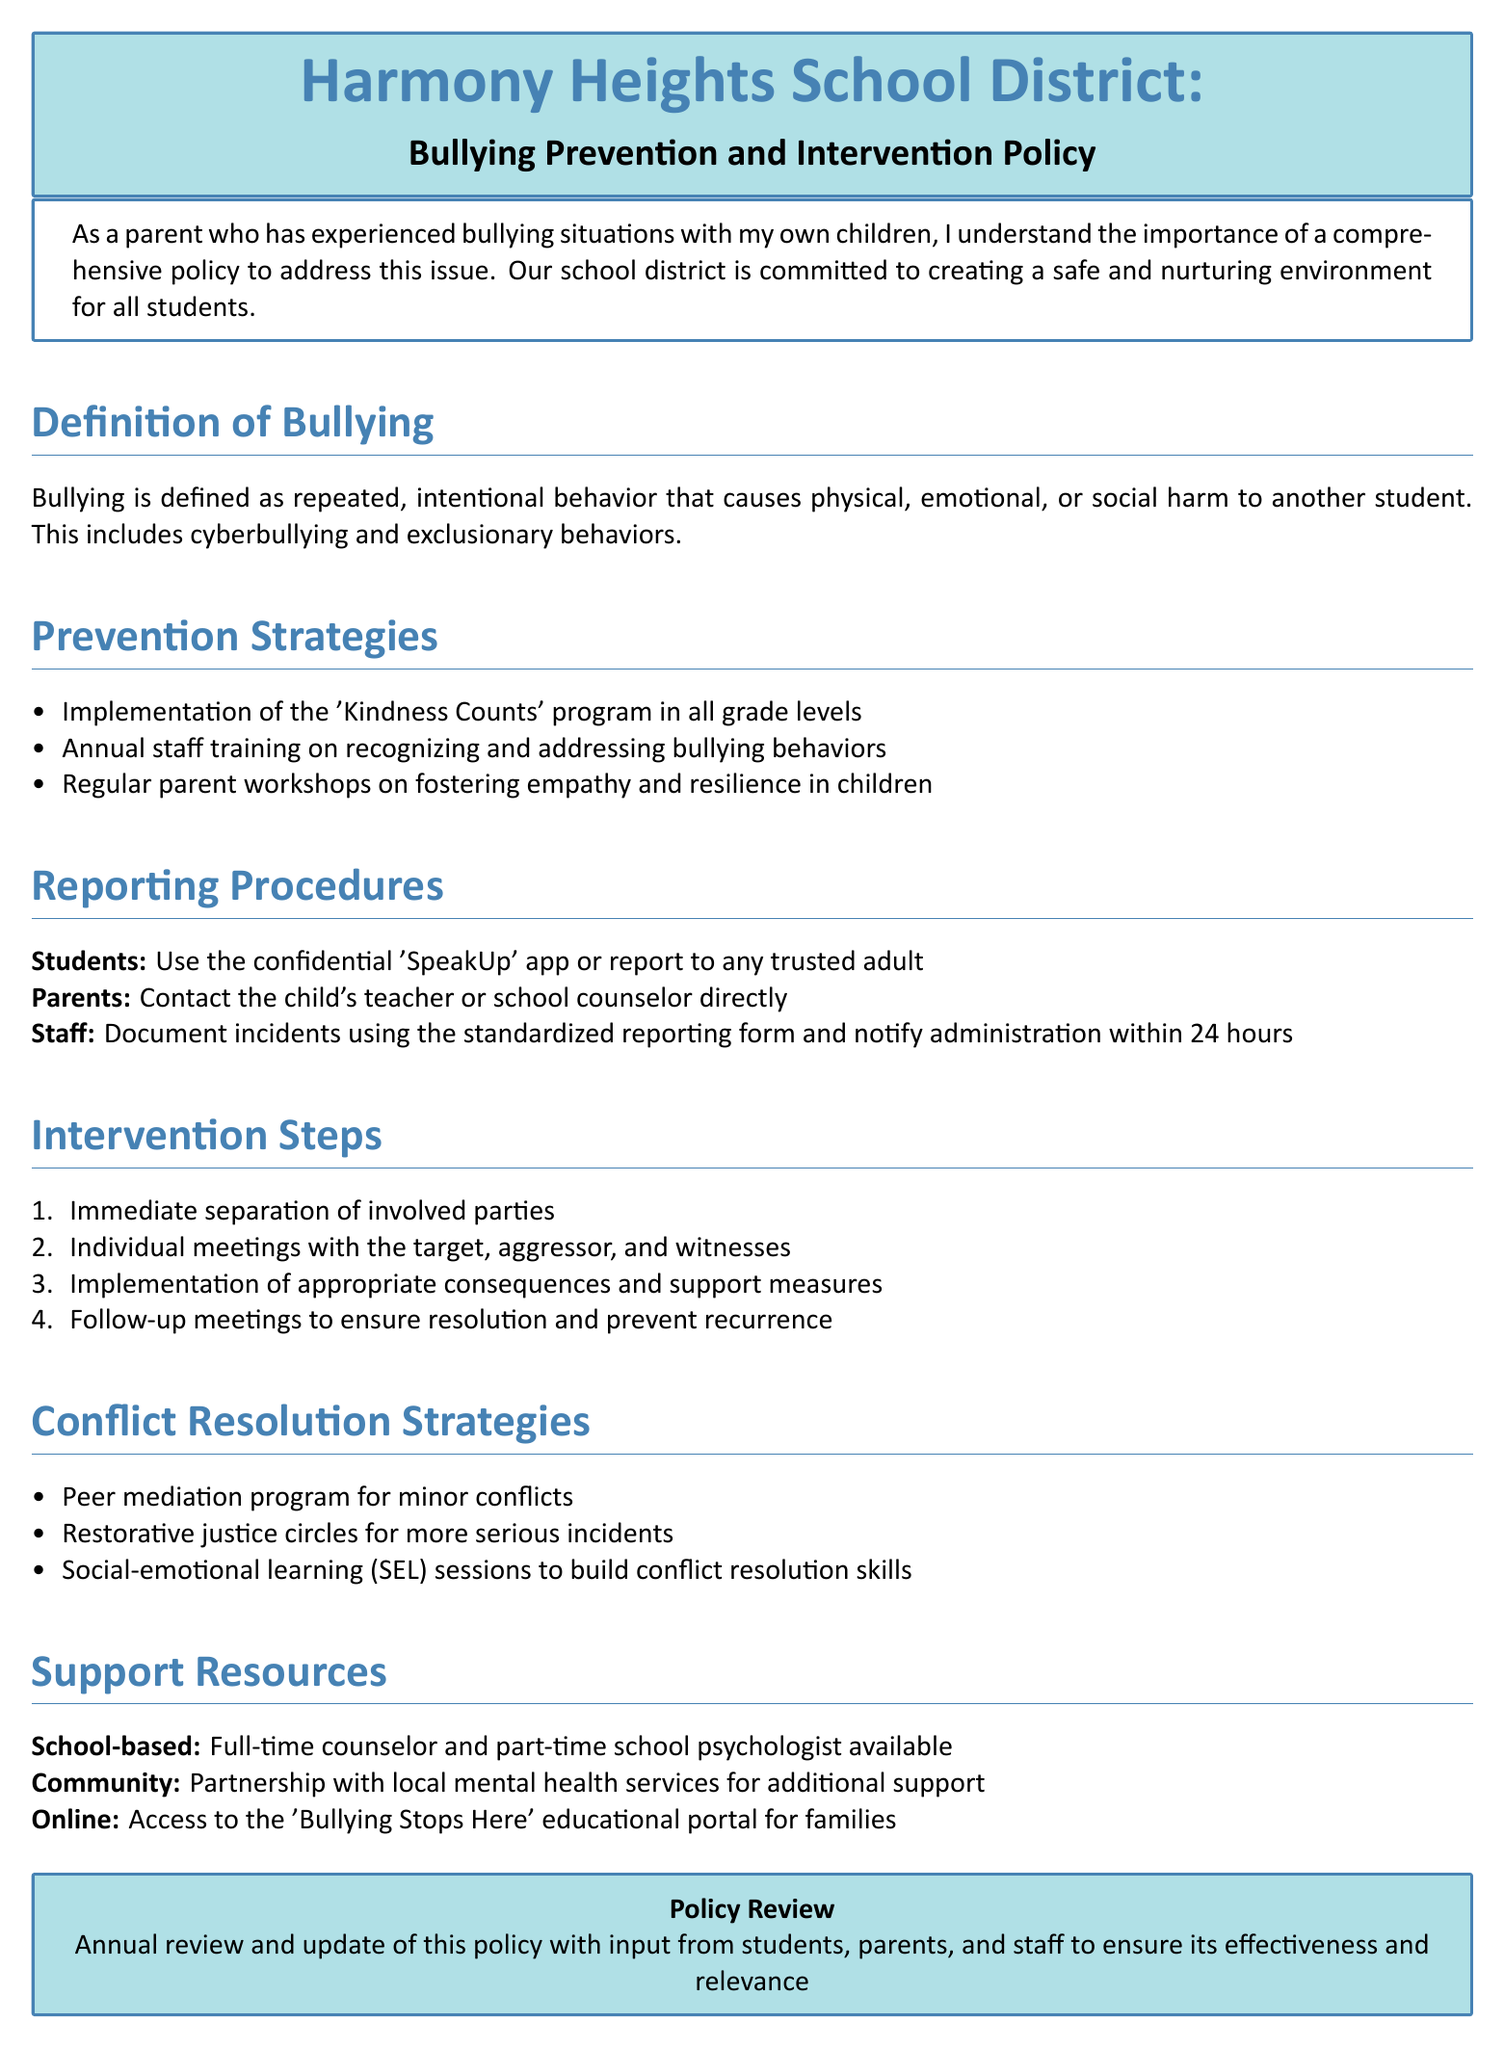What is the title of the policy document? The title is clearly stated as "Bullying Prevention and Intervention Policy."
Answer: Bullying Prevention and Intervention Policy What program is implemented for all grade levels? The document mentions the 'Kindness Counts' program as a prevention strategy.
Answer: Kindness Counts How can students report bullying incidents? Students can report using the confidential 'SpeakUp' app or to a trusted adult.
Answer: 'SpeakUp' app What is the first step in the intervention process? The first step in the intervention process is the immediate separation of involved parties.
Answer: Immediate separation What type of program is used for minor conflicts? The document specifies a peer mediation program for addressing minor conflicts.
Answer: Peer mediation program What resources are available through the community? The school district has a partnership with local mental health services for additional support.
Answer: Local mental health services How often is the policy reviewed? The policy is reviewed annually, as stated in the document.
Answer: Annually What session type is designed to build conflict resolution skills? The document mentions social-emotional learning (SEL) sessions for this purpose.
Answer: Social-emotional learning (SEL) sessions 